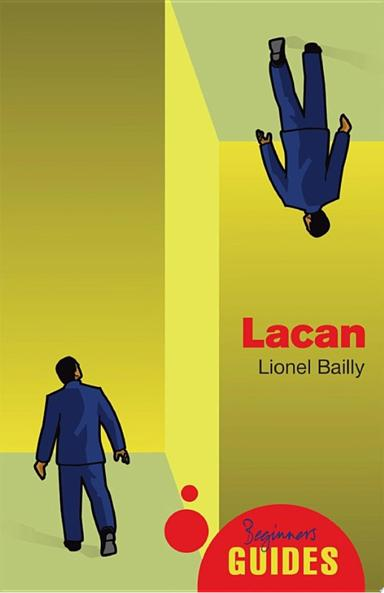How does the 'Beginner's Guides' series help a novice understand complex topics? The 'Beginner's Guides' series breaks down complex topics into comprehensible segments, using straightforward language and real-world examples. It equips novices with foundational knowledge and enhances understanding through structured learning paths. 